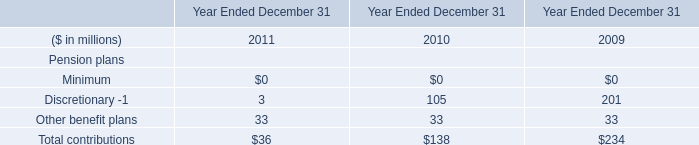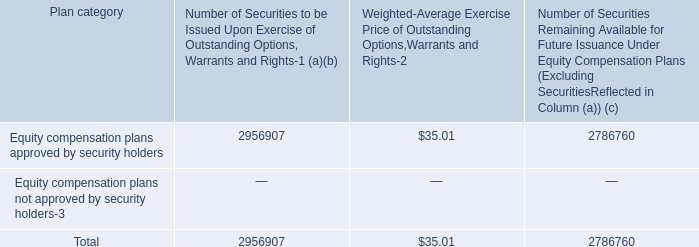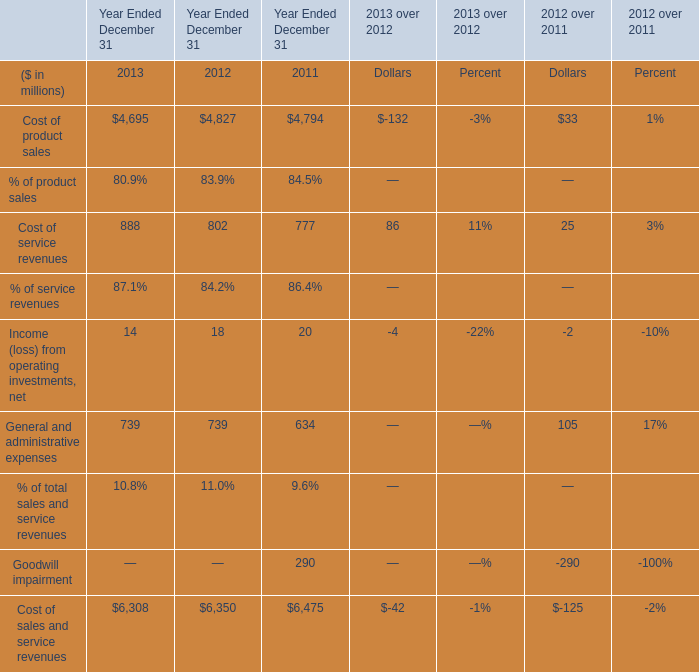what portion of the equity compensation plan approved by security holders is to be issued upon the exercise of the outstanding options warrants and rights? 
Computations: (2956907 / (2956907 + 2786760))
Answer: 0.51481. 